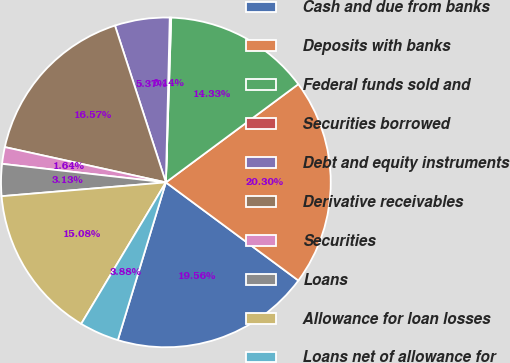Convert chart. <chart><loc_0><loc_0><loc_500><loc_500><pie_chart><fcel>Cash and due from banks<fcel>Deposits with banks<fcel>Federal funds sold and<fcel>Securities borrowed<fcel>Debt and equity instruments<fcel>Derivative receivables<fcel>Securities<fcel>Loans<fcel>Allowance for loan losses<fcel>Loans net of allowance for<nl><fcel>19.56%<fcel>20.3%<fcel>14.33%<fcel>0.14%<fcel>5.37%<fcel>16.57%<fcel>1.64%<fcel>3.13%<fcel>15.08%<fcel>3.88%<nl></chart> 